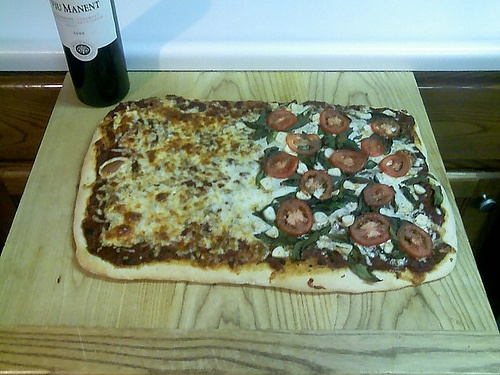Describe the objects in this image and their specific colors. I can see dining table in lightblue, olive, darkgray, and gray tones, pizza in lightblue, olive, gray, and darkgray tones, and bottle in lightblue, black, and darkgray tones in this image. 